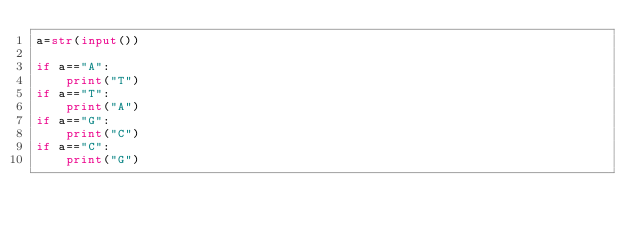Convert code to text. <code><loc_0><loc_0><loc_500><loc_500><_Python_>a=str(input())
 
if a=="A":
    print("T")
if a=="T":
    print("A")
if a=="G":
    print("C")
if a=="C":
    print("G")</code> 